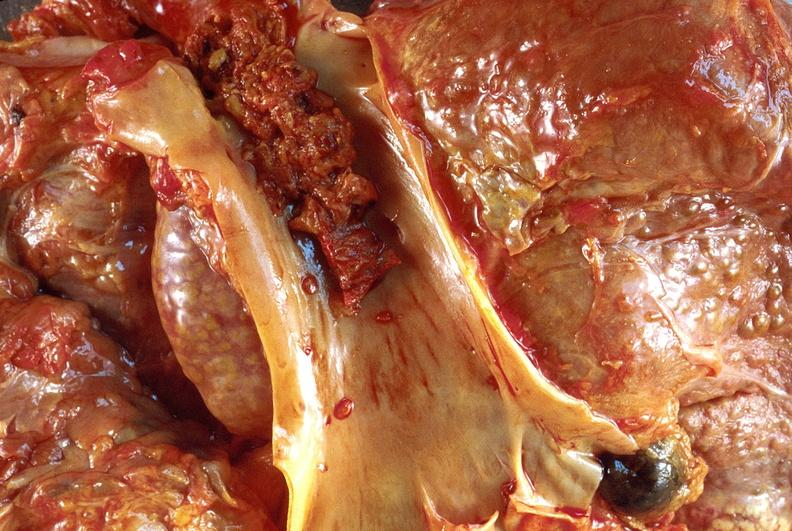what is present?
Answer the question using a single word or phrase. Hepatobiliary 